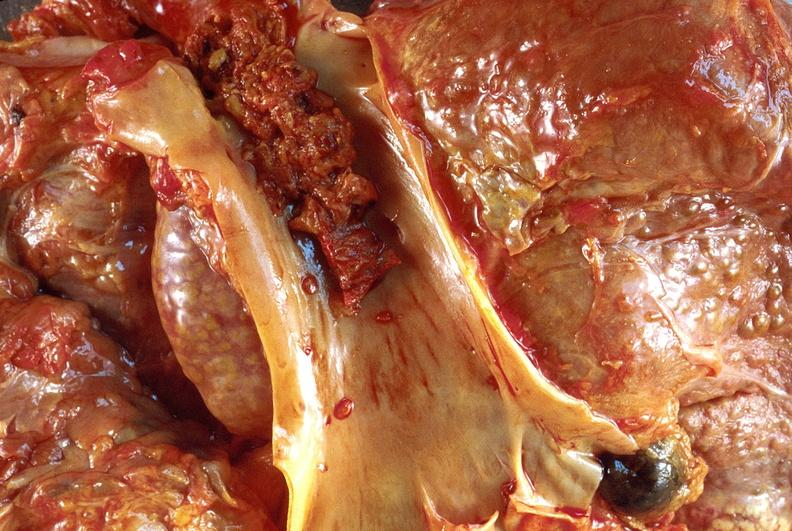what is present?
Answer the question using a single word or phrase. Hepatobiliary 